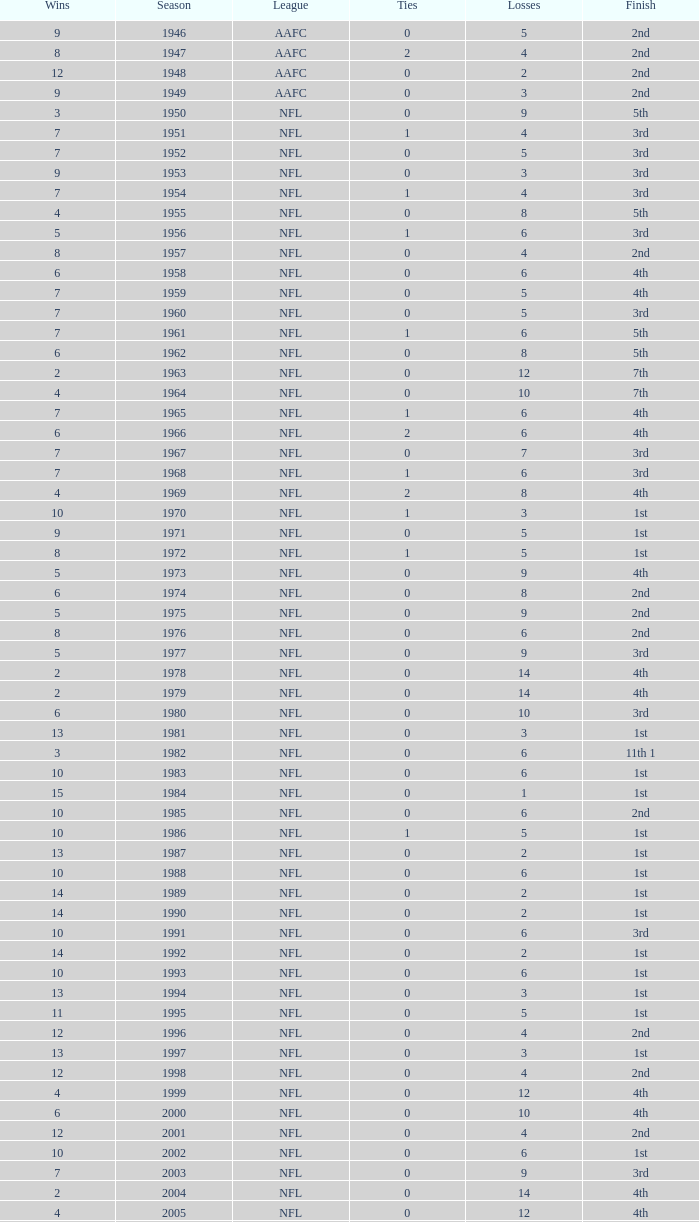What is the number of losses when the ties are lesser than 0? 0.0. 